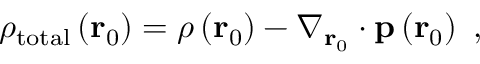Convert formula to latex. <formula><loc_0><loc_0><loc_500><loc_500>\rho _ { t o t a l } \left ( r _ { 0 } \right ) = \rho \left ( r _ { 0 } \right ) - \nabla _ { r _ { 0 } } \cdot p \left ( r _ { 0 } \right ) \ ,</formula> 